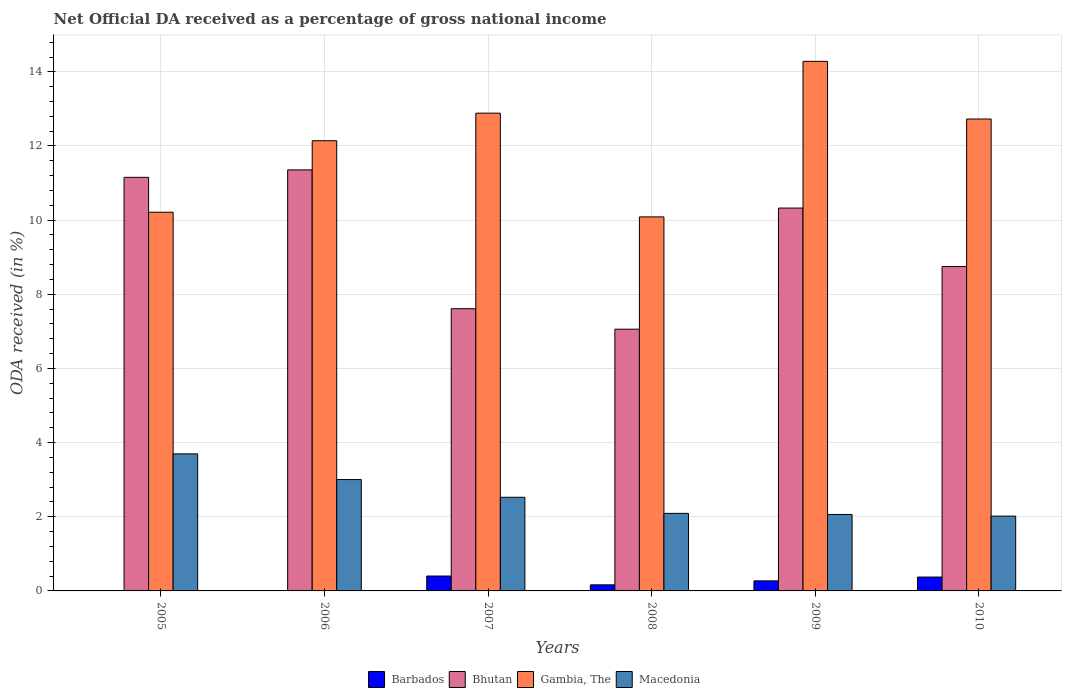How many groups of bars are there?
Keep it short and to the point. 6. Are the number of bars on each tick of the X-axis equal?
Provide a short and direct response. No. What is the label of the 2nd group of bars from the left?
Ensure brevity in your answer.  2006. In how many cases, is the number of bars for a given year not equal to the number of legend labels?
Your response must be concise. 2. What is the net official DA received in Gambia, The in 2006?
Your response must be concise. 12.14. Across all years, what is the maximum net official DA received in Barbados?
Ensure brevity in your answer.  0.4. Across all years, what is the minimum net official DA received in Macedonia?
Your answer should be compact. 2.02. In which year was the net official DA received in Macedonia maximum?
Your answer should be very brief. 2005. What is the total net official DA received in Macedonia in the graph?
Keep it short and to the point. 15.4. What is the difference between the net official DA received in Gambia, The in 2007 and that in 2010?
Offer a very short reply. 0.16. What is the difference between the net official DA received in Barbados in 2010 and the net official DA received in Macedonia in 2009?
Offer a very short reply. -1.69. What is the average net official DA received in Barbados per year?
Your answer should be compact. 0.2. In the year 2010, what is the difference between the net official DA received in Bhutan and net official DA received in Macedonia?
Provide a short and direct response. 6.73. In how many years, is the net official DA received in Gambia, The greater than 11.6 %?
Your answer should be compact. 4. What is the ratio of the net official DA received in Macedonia in 2005 to that in 2008?
Offer a terse response. 1.77. What is the difference between the highest and the second highest net official DA received in Macedonia?
Your answer should be very brief. 0.69. What is the difference between the highest and the lowest net official DA received in Gambia, The?
Provide a succinct answer. 4.2. Is the sum of the net official DA received in Bhutan in 2005 and 2008 greater than the maximum net official DA received in Barbados across all years?
Keep it short and to the point. Yes. Is it the case that in every year, the sum of the net official DA received in Gambia, The and net official DA received in Bhutan is greater than the net official DA received in Macedonia?
Your answer should be very brief. Yes. Are all the bars in the graph horizontal?
Give a very brief answer. No. Are the values on the major ticks of Y-axis written in scientific E-notation?
Your response must be concise. No. Does the graph contain any zero values?
Offer a terse response. Yes. Where does the legend appear in the graph?
Ensure brevity in your answer.  Bottom center. How are the legend labels stacked?
Keep it short and to the point. Horizontal. What is the title of the graph?
Your answer should be very brief. Net Official DA received as a percentage of gross national income. What is the label or title of the X-axis?
Your answer should be compact. Years. What is the label or title of the Y-axis?
Your answer should be very brief. ODA received (in %). What is the ODA received (in %) in Barbados in 2005?
Your response must be concise. 0. What is the ODA received (in %) of Bhutan in 2005?
Offer a very short reply. 11.15. What is the ODA received (in %) of Gambia, The in 2005?
Provide a succinct answer. 10.21. What is the ODA received (in %) in Macedonia in 2005?
Your answer should be very brief. 3.7. What is the ODA received (in %) of Barbados in 2006?
Ensure brevity in your answer.  0. What is the ODA received (in %) in Bhutan in 2006?
Offer a very short reply. 11.36. What is the ODA received (in %) in Gambia, The in 2006?
Provide a short and direct response. 12.14. What is the ODA received (in %) of Macedonia in 2006?
Keep it short and to the point. 3. What is the ODA received (in %) in Barbados in 2007?
Give a very brief answer. 0.4. What is the ODA received (in %) in Bhutan in 2007?
Ensure brevity in your answer.  7.61. What is the ODA received (in %) in Gambia, The in 2007?
Make the answer very short. 12.89. What is the ODA received (in %) in Macedonia in 2007?
Your response must be concise. 2.53. What is the ODA received (in %) in Barbados in 2008?
Keep it short and to the point. 0.16. What is the ODA received (in %) of Bhutan in 2008?
Offer a very short reply. 7.06. What is the ODA received (in %) in Gambia, The in 2008?
Ensure brevity in your answer.  10.09. What is the ODA received (in %) in Macedonia in 2008?
Provide a succinct answer. 2.09. What is the ODA received (in %) of Barbados in 2009?
Keep it short and to the point. 0.27. What is the ODA received (in %) in Bhutan in 2009?
Your answer should be compact. 10.33. What is the ODA received (in %) of Gambia, The in 2009?
Your answer should be compact. 14.28. What is the ODA received (in %) in Macedonia in 2009?
Your answer should be very brief. 2.06. What is the ODA received (in %) of Barbados in 2010?
Provide a succinct answer. 0.37. What is the ODA received (in %) of Bhutan in 2010?
Offer a very short reply. 8.75. What is the ODA received (in %) of Gambia, The in 2010?
Your answer should be very brief. 12.73. What is the ODA received (in %) in Macedonia in 2010?
Provide a succinct answer. 2.02. Across all years, what is the maximum ODA received (in %) in Barbados?
Your answer should be compact. 0.4. Across all years, what is the maximum ODA received (in %) of Bhutan?
Give a very brief answer. 11.36. Across all years, what is the maximum ODA received (in %) in Gambia, The?
Your response must be concise. 14.28. Across all years, what is the maximum ODA received (in %) in Macedonia?
Ensure brevity in your answer.  3.7. Across all years, what is the minimum ODA received (in %) of Bhutan?
Offer a very short reply. 7.06. Across all years, what is the minimum ODA received (in %) of Gambia, The?
Provide a short and direct response. 10.09. Across all years, what is the minimum ODA received (in %) of Macedonia?
Your response must be concise. 2.02. What is the total ODA received (in %) of Barbados in the graph?
Provide a succinct answer. 1.21. What is the total ODA received (in %) of Bhutan in the graph?
Provide a succinct answer. 56.26. What is the total ODA received (in %) in Gambia, The in the graph?
Give a very brief answer. 72.34. What is the total ODA received (in %) of Macedonia in the graph?
Offer a terse response. 15.4. What is the difference between the ODA received (in %) of Bhutan in 2005 and that in 2006?
Offer a very short reply. -0.2. What is the difference between the ODA received (in %) of Gambia, The in 2005 and that in 2006?
Provide a succinct answer. -1.93. What is the difference between the ODA received (in %) of Macedonia in 2005 and that in 2006?
Your answer should be compact. 0.69. What is the difference between the ODA received (in %) of Bhutan in 2005 and that in 2007?
Your answer should be very brief. 3.54. What is the difference between the ODA received (in %) of Gambia, The in 2005 and that in 2007?
Ensure brevity in your answer.  -2.67. What is the difference between the ODA received (in %) of Macedonia in 2005 and that in 2007?
Provide a short and direct response. 1.17. What is the difference between the ODA received (in %) in Bhutan in 2005 and that in 2008?
Offer a terse response. 4.1. What is the difference between the ODA received (in %) of Gambia, The in 2005 and that in 2008?
Offer a terse response. 0.13. What is the difference between the ODA received (in %) in Macedonia in 2005 and that in 2008?
Your response must be concise. 1.61. What is the difference between the ODA received (in %) of Bhutan in 2005 and that in 2009?
Provide a succinct answer. 0.83. What is the difference between the ODA received (in %) in Gambia, The in 2005 and that in 2009?
Keep it short and to the point. -4.07. What is the difference between the ODA received (in %) in Macedonia in 2005 and that in 2009?
Keep it short and to the point. 1.63. What is the difference between the ODA received (in %) of Bhutan in 2005 and that in 2010?
Your response must be concise. 2.41. What is the difference between the ODA received (in %) in Gambia, The in 2005 and that in 2010?
Provide a succinct answer. -2.51. What is the difference between the ODA received (in %) of Macedonia in 2005 and that in 2010?
Ensure brevity in your answer.  1.68. What is the difference between the ODA received (in %) of Bhutan in 2006 and that in 2007?
Keep it short and to the point. 3.74. What is the difference between the ODA received (in %) of Gambia, The in 2006 and that in 2007?
Offer a terse response. -0.74. What is the difference between the ODA received (in %) of Macedonia in 2006 and that in 2007?
Provide a succinct answer. 0.48. What is the difference between the ODA received (in %) of Bhutan in 2006 and that in 2008?
Offer a terse response. 4.3. What is the difference between the ODA received (in %) in Gambia, The in 2006 and that in 2008?
Make the answer very short. 2.05. What is the difference between the ODA received (in %) in Macedonia in 2006 and that in 2008?
Make the answer very short. 0.91. What is the difference between the ODA received (in %) in Bhutan in 2006 and that in 2009?
Offer a very short reply. 1.03. What is the difference between the ODA received (in %) of Gambia, The in 2006 and that in 2009?
Ensure brevity in your answer.  -2.14. What is the difference between the ODA received (in %) of Macedonia in 2006 and that in 2009?
Make the answer very short. 0.94. What is the difference between the ODA received (in %) of Bhutan in 2006 and that in 2010?
Make the answer very short. 2.61. What is the difference between the ODA received (in %) in Gambia, The in 2006 and that in 2010?
Keep it short and to the point. -0.59. What is the difference between the ODA received (in %) of Macedonia in 2006 and that in 2010?
Keep it short and to the point. 0.99. What is the difference between the ODA received (in %) in Barbados in 2007 and that in 2008?
Give a very brief answer. 0.24. What is the difference between the ODA received (in %) of Bhutan in 2007 and that in 2008?
Your answer should be very brief. 0.55. What is the difference between the ODA received (in %) in Gambia, The in 2007 and that in 2008?
Ensure brevity in your answer.  2.8. What is the difference between the ODA received (in %) of Macedonia in 2007 and that in 2008?
Ensure brevity in your answer.  0.43. What is the difference between the ODA received (in %) of Barbados in 2007 and that in 2009?
Your answer should be very brief. 0.13. What is the difference between the ODA received (in %) in Bhutan in 2007 and that in 2009?
Offer a terse response. -2.71. What is the difference between the ODA received (in %) in Gambia, The in 2007 and that in 2009?
Give a very brief answer. -1.4. What is the difference between the ODA received (in %) in Macedonia in 2007 and that in 2009?
Offer a very short reply. 0.46. What is the difference between the ODA received (in %) of Barbados in 2007 and that in 2010?
Make the answer very short. 0.03. What is the difference between the ODA received (in %) of Bhutan in 2007 and that in 2010?
Give a very brief answer. -1.14. What is the difference between the ODA received (in %) in Gambia, The in 2007 and that in 2010?
Provide a short and direct response. 0.16. What is the difference between the ODA received (in %) of Macedonia in 2007 and that in 2010?
Keep it short and to the point. 0.51. What is the difference between the ODA received (in %) of Barbados in 2008 and that in 2009?
Provide a succinct answer. -0.11. What is the difference between the ODA received (in %) of Bhutan in 2008 and that in 2009?
Provide a succinct answer. -3.27. What is the difference between the ODA received (in %) of Gambia, The in 2008 and that in 2009?
Keep it short and to the point. -4.2. What is the difference between the ODA received (in %) of Macedonia in 2008 and that in 2009?
Provide a short and direct response. 0.03. What is the difference between the ODA received (in %) of Barbados in 2008 and that in 2010?
Offer a very short reply. -0.21. What is the difference between the ODA received (in %) of Bhutan in 2008 and that in 2010?
Provide a short and direct response. -1.69. What is the difference between the ODA received (in %) of Gambia, The in 2008 and that in 2010?
Provide a short and direct response. -2.64. What is the difference between the ODA received (in %) of Macedonia in 2008 and that in 2010?
Provide a succinct answer. 0.07. What is the difference between the ODA received (in %) of Barbados in 2009 and that in 2010?
Provide a succinct answer. -0.1. What is the difference between the ODA received (in %) of Bhutan in 2009 and that in 2010?
Your response must be concise. 1.58. What is the difference between the ODA received (in %) in Gambia, The in 2009 and that in 2010?
Give a very brief answer. 1.55. What is the difference between the ODA received (in %) of Macedonia in 2009 and that in 2010?
Your answer should be very brief. 0.04. What is the difference between the ODA received (in %) of Bhutan in 2005 and the ODA received (in %) of Gambia, The in 2006?
Offer a very short reply. -0.99. What is the difference between the ODA received (in %) in Bhutan in 2005 and the ODA received (in %) in Macedonia in 2006?
Offer a terse response. 8.15. What is the difference between the ODA received (in %) in Gambia, The in 2005 and the ODA received (in %) in Macedonia in 2006?
Offer a very short reply. 7.21. What is the difference between the ODA received (in %) of Bhutan in 2005 and the ODA received (in %) of Gambia, The in 2007?
Your answer should be compact. -1.73. What is the difference between the ODA received (in %) of Bhutan in 2005 and the ODA received (in %) of Macedonia in 2007?
Offer a terse response. 8.63. What is the difference between the ODA received (in %) of Gambia, The in 2005 and the ODA received (in %) of Macedonia in 2007?
Offer a terse response. 7.69. What is the difference between the ODA received (in %) in Bhutan in 2005 and the ODA received (in %) in Gambia, The in 2008?
Ensure brevity in your answer.  1.07. What is the difference between the ODA received (in %) in Bhutan in 2005 and the ODA received (in %) in Macedonia in 2008?
Provide a succinct answer. 9.06. What is the difference between the ODA received (in %) of Gambia, The in 2005 and the ODA received (in %) of Macedonia in 2008?
Your answer should be compact. 8.12. What is the difference between the ODA received (in %) of Bhutan in 2005 and the ODA received (in %) of Gambia, The in 2009?
Provide a short and direct response. -3.13. What is the difference between the ODA received (in %) of Bhutan in 2005 and the ODA received (in %) of Macedonia in 2009?
Provide a succinct answer. 9.09. What is the difference between the ODA received (in %) in Gambia, The in 2005 and the ODA received (in %) in Macedonia in 2009?
Provide a short and direct response. 8.15. What is the difference between the ODA received (in %) in Bhutan in 2005 and the ODA received (in %) in Gambia, The in 2010?
Keep it short and to the point. -1.57. What is the difference between the ODA received (in %) of Bhutan in 2005 and the ODA received (in %) of Macedonia in 2010?
Keep it short and to the point. 9.14. What is the difference between the ODA received (in %) in Gambia, The in 2005 and the ODA received (in %) in Macedonia in 2010?
Offer a terse response. 8.2. What is the difference between the ODA received (in %) of Bhutan in 2006 and the ODA received (in %) of Gambia, The in 2007?
Provide a short and direct response. -1.53. What is the difference between the ODA received (in %) in Bhutan in 2006 and the ODA received (in %) in Macedonia in 2007?
Ensure brevity in your answer.  8.83. What is the difference between the ODA received (in %) in Gambia, The in 2006 and the ODA received (in %) in Macedonia in 2007?
Give a very brief answer. 9.62. What is the difference between the ODA received (in %) of Bhutan in 2006 and the ODA received (in %) of Gambia, The in 2008?
Ensure brevity in your answer.  1.27. What is the difference between the ODA received (in %) in Bhutan in 2006 and the ODA received (in %) in Macedonia in 2008?
Keep it short and to the point. 9.26. What is the difference between the ODA received (in %) of Gambia, The in 2006 and the ODA received (in %) of Macedonia in 2008?
Keep it short and to the point. 10.05. What is the difference between the ODA received (in %) of Bhutan in 2006 and the ODA received (in %) of Gambia, The in 2009?
Your answer should be compact. -2.93. What is the difference between the ODA received (in %) in Bhutan in 2006 and the ODA received (in %) in Macedonia in 2009?
Provide a succinct answer. 9.29. What is the difference between the ODA received (in %) in Gambia, The in 2006 and the ODA received (in %) in Macedonia in 2009?
Offer a very short reply. 10.08. What is the difference between the ODA received (in %) of Bhutan in 2006 and the ODA received (in %) of Gambia, The in 2010?
Offer a terse response. -1.37. What is the difference between the ODA received (in %) in Bhutan in 2006 and the ODA received (in %) in Macedonia in 2010?
Make the answer very short. 9.34. What is the difference between the ODA received (in %) in Gambia, The in 2006 and the ODA received (in %) in Macedonia in 2010?
Make the answer very short. 10.12. What is the difference between the ODA received (in %) of Barbados in 2007 and the ODA received (in %) of Bhutan in 2008?
Ensure brevity in your answer.  -6.66. What is the difference between the ODA received (in %) of Barbados in 2007 and the ODA received (in %) of Gambia, The in 2008?
Provide a succinct answer. -9.69. What is the difference between the ODA received (in %) of Barbados in 2007 and the ODA received (in %) of Macedonia in 2008?
Your response must be concise. -1.69. What is the difference between the ODA received (in %) in Bhutan in 2007 and the ODA received (in %) in Gambia, The in 2008?
Keep it short and to the point. -2.48. What is the difference between the ODA received (in %) in Bhutan in 2007 and the ODA received (in %) in Macedonia in 2008?
Offer a very short reply. 5.52. What is the difference between the ODA received (in %) of Gambia, The in 2007 and the ODA received (in %) of Macedonia in 2008?
Offer a terse response. 10.79. What is the difference between the ODA received (in %) in Barbados in 2007 and the ODA received (in %) in Bhutan in 2009?
Provide a short and direct response. -9.92. What is the difference between the ODA received (in %) of Barbados in 2007 and the ODA received (in %) of Gambia, The in 2009?
Keep it short and to the point. -13.88. What is the difference between the ODA received (in %) of Barbados in 2007 and the ODA received (in %) of Macedonia in 2009?
Offer a terse response. -1.66. What is the difference between the ODA received (in %) of Bhutan in 2007 and the ODA received (in %) of Gambia, The in 2009?
Keep it short and to the point. -6.67. What is the difference between the ODA received (in %) in Bhutan in 2007 and the ODA received (in %) in Macedonia in 2009?
Offer a very short reply. 5.55. What is the difference between the ODA received (in %) of Gambia, The in 2007 and the ODA received (in %) of Macedonia in 2009?
Keep it short and to the point. 10.82. What is the difference between the ODA received (in %) of Barbados in 2007 and the ODA received (in %) of Bhutan in 2010?
Give a very brief answer. -8.35. What is the difference between the ODA received (in %) in Barbados in 2007 and the ODA received (in %) in Gambia, The in 2010?
Ensure brevity in your answer.  -12.33. What is the difference between the ODA received (in %) in Barbados in 2007 and the ODA received (in %) in Macedonia in 2010?
Provide a short and direct response. -1.62. What is the difference between the ODA received (in %) of Bhutan in 2007 and the ODA received (in %) of Gambia, The in 2010?
Offer a terse response. -5.12. What is the difference between the ODA received (in %) in Bhutan in 2007 and the ODA received (in %) in Macedonia in 2010?
Offer a terse response. 5.59. What is the difference between the ODA received (in %) of Gambia, The in 2007 and the ODA received (in %) of Macedonia in 2010?
Provide a succinct answer. 10.87. What is the difference between the ODA received (in %) of Barbados in 2008 and the ODA received (in %) of Bhutan in 2009?
Your response must be concise. -10.16. What is the difference between the ODA received (in %) of Barbados in 2008 and the ODA received (in %) of Gambia, The in 2009?
Your response must be concise. -14.12. What is the difference between the ODA received (in %) of Barbados in 2008 and the ODA received (in %) of Macedonia in 2009?
Provide a succinct answer. -1.9. What is the difference between the ODA received (in %) of Bhutan in 2008 and the ODA received (in %) of Gambia, The in 2009?
Give a very brief answer. -7.22. What is the difference between the ODA received (in %) of Bhutan in 2008 and the ODA received (in %) of Macedonia in 2009?
Make the answer very short. 5. What is the difference between the ODA received (in %) in Gambia, The in 2008 and the ODA received (in %) in Macedonia in 2009?
Keep it short and to the point. 8.03. What is the difference between the ODA received (in %) in Barbados in 2008 and the ODA received (in %) in Bhutan in 2010?
Make the answer very short. -8.58. What is the difference between the ODA received (in %) in Barbados in 2008 and the ODA received (in %) in Gambia, The in 2010?
Your response must be concise. -12.56. What is the difference between the ODA received (in %) in Barbados in 2008 and the ODA received (in %) in Macedonia in 2010?
Offer a terse response. -1.85. What is the difference between the ODA received (in %) in Bhutan in 2008 and the ODA received (in %) in Gambia, The in 2010?
Your response must be concise. -5.67. What is the difference between the ODA received (in %) of Bhutan in 2008 and the ODA received (in %) of Macedonia in 2010?
Offer a terse response. 5.04. What is the difference between the ODA received (in %) of Gambia, The in 2008 and the ODA received (in %) of Macedonia in 2010?
Provide a succinct answer. 8.07. What is the difference between the ODA received (in %) of Barbados in 2009 and the ODA received (in %) of Bhutan in 2010?
Provide a short and direct response. -8.48. What is the difference between the ODA received (in %) in Barbados in 2009 and the ODA received (in %) in Gambia, The in 2010?
Your answer should be very brief. -12.46. What is the difference between the ODA received (in %) in Barbados in 2009 and the ODA received (in %) in Macedonia in 2010?
Your answer should be compact. -1.75. What is the difference between the ODA received (in %) of Bhutan in 2009 and the ODA received (in %) of Gambia, The in 2010?
Your answer should be very brief. -2.4. What is the difference between the ODA received (in %) of Bhutan in 2009 and the ODA received (in %) of Macedonia in 2010?
Your answer should be compact. 8.31. What is the difference between the ODA received (in %) of Gambia, The in 2009 and the ODA received (in %) of Macedonia in 2010?
Your answer should be compact. 12.26. What is the average ODA received (in %) in Barbados per year?
Keep it short and to the point. 0.2. What is the average ODA received (in %) of Bhutan per year?
Provide a succinct answer. 9.38. What is the average ODA received (in %) in Gambia, The per year?
Provide a short and direct response. 12.06. What is the average ODA received (in %) of Macedonia per year?
Offer a terse response. 2.57. In the year 2005, what is the difference between the ODA received (in %) in Bhutan and ODA received (in %) in Gambia, The?
Your response must be concise. 0.94. In the year 2005, what is the difference between the ODA received (in %) of Bhutan and ODA received (in %) of Macedonia?
Your answer should be very brief. 7.46. In the year 2005, what is the difference between the ODA received (in %) of Gambia, The and ODA received (in %) of Macedonia?
Provide a short and direct response. 6.52. In the year 2006, what is the difference between the ODA received (in %) in Bhutan and ODA received (in %) in Gambia, The?
Your response must be concise. -0.79. In the year 2006, what is the difference between the ODA received (in %) in Bhutan and ODA received (in %) in Macedonia?
Your answer should be compact. 8.35. In the year 2006, what is the difference between the ODA received (in %) of Gambia, The and ODA received (in %) of Macedonia?
Keep it short and to the point. 9.14. In the year 2007, what is the difference between the ODA received (in %) of Barbados and ODA received (in %) of Bhutan?
Ensure brevity in your answer.  -7.21. In the year 2007, what is the difference between the ODA received (in %) in Barbados and ODA received (in %) in Gambia, The?
Keep it short and to the point. -12.48. In the year 2007, what is the difference between the ODA received (in %) of Barbados and ODA received (in %) of Macedonia?
Your response must be concise. -2.12. In the year 2007, what is the difference between the ODA received (in %) of Bhutan and ODA received (in %) of Gambia, The?
Provide a succinct answer. -5.27. In the year 2007, what is the difference between the ODA received (in %) of Bhutan and ODA received (in %) of Macedonia?
Offer a very short reply. 5.09. In the year 2007, what is the difference between the ODA received (in %) of Gambia, The and ODA received (in %) of Macedonia?
Ensure brevity in your answer.  10.36. In the year 2008, what is the difference between the ODA received (in %) of Barbados and ODA received (in %) of Bhutan?
Your answer should be compact. -6.9. In the year 2008, what is the difference between the ODA received (in %) in Barbados and ODA received (in %) in Gambia, The?
Your answer should be very brief. -9.92. In the year 2008, what is the difference between the ODA received (in %) of Barbados and ODA received (in %) of Macedonia?
Give a very brief answer. -1.93. In the year 2008, what is the difference between the ODA received (in %) of Bhutan and ODA received (in %) of Gambia, The?
Make the answer very short. -3.03. In the year 2008, what is the difference between the ODA received (in %) in Bhutan and ODA received (in %) in Macedonia?
Your answer should be compact. 4.97. In the year 2008, what is the difference between the ODA received (in %) of Gambia, The and ODA received (in %) of Macedonia?
Your answer should be compact. 8. In the year 2009, what is the difference between the ODA received (in %) of Barbados and ODA received (in %) of Bhutan?
Keep it short and to the point. -10.06. In the year 2009, what is the difference between the ODA received (in %) of Barbados and ODA received (in %) of Gambia, The?
Ensure brevity in your answer.  -14.01. In the year 2009, what is the difference between the ODA received (in %) of Barbados and ODA received (in %) of Macedonia?
Provide a succinct answer. -1.79. In the year 2009, what is the difference between the ODA received (in %) of Bhutan and ODA received (in %) of Gambia, The?
Provide a succinct answer. -3.96. In the year 2009, what is the difference between the ODA received (in %) of Bhutan and ODA received (in %) of Macedonia?
Your answer should be very brief. 8.26. In the year 2009, what is the difference between the ODA received (in %) in Gambia, The and ODA received (in %) in Macedonia?
Provide a short and direct response. 12.22. In the year 2010, what is the difference between the ODA received (in %) in Barbados and ODA received (in %) in Bhutan?
Offer a very short reply. -8.37. In the year 2010, what is the difference between the ODA received (in %) of Barbados and ODA received (in %) of Gambia, The?
Provide a succinct answer. -12.35. In the year 2010, what is the difference between the ODA received (in %) in Barbados and ODA received (in %) in Macedonia?
Give a very brief answer. -1.64. In the year 2010, what is the difference between the ODA received (in %) in Bhutan and ODA received (in %) in Gambia, The?
Offer a terse response. -3.98. In the year 2010, what is the difference between the ODA received (in %) of Bhutan and ODA received (in %) of Macedonia?
Offer a terse response. 6.73. In the year 2010, what is the difference between the ODA received (in %) of Gambia, The and ODA received (in %) of Macedonia?
Give a very brief answer. 10.71. What is the ratio of the ODA received (in %) in Bhutan in 2005 to that in 2006?
Your response must be concise. 0.98. What is the ratio of the ODA received (in %) of Gambia, The in 2005 to that in 2006?
Make the answer very short. 0.84. What is the ratio of the ODA received (in %) in Macedonia in 2005 to that in 2006?
Ensure brevity in your answer.  1.23. What is the ratio of the ODA received (in %) in Bhutan in 2005 to that in 2007?
Provide a short and direct response. 1.47. What is the ratio of the ODA received (in %) of Gambia, The in 2005 to that in 2007?
Your answer should be very brief. 0.79. What is the ratio of the ODA received (in %) of Macedonia in 2005 to that in 2007?
Keep it short and to the point. 1.46. What is the ratio of the ODA received (in %) of Bhutan in 2005 to that in 2008?
Give a very brief answer. 1.58. What is the ratio of the ODA received (in %) in Gambia, The in 2005 to that in 2008?
Offer a very short reply. 1.01. What is the ratio of the ODA received (in %) of Macedonia in 2005 to that in 2008?
Provide a succinct answer. 1.77. What is the ratio of the ODA received (in %) of Bhutan in 2005 to that in 2009?
Make the answer very short. 1.08. What is the ratio of the ODA received (in %) in Gambia, The in 2005 to that in 2009?
Your response must be concise. 0.72. What is the ratio of the ODA received (in %) of Macedonia in 2005 to that in 2009?
Your answer should be very brief. 1.79. What is the ratio of the ODA received (in %) in Bhutan in 2005 to that in 2010?
Make the answer very short. 1.28. What is the ratio of the ODA received (in %) of Gambia, The in 2005 to that in 2010?
Ensure brevity in your answer.  0.8. What is the ratio of the ODA received (in %) of Macedonia in 2005 to that in 2010?
Your response must be concise. 1.83. What is the ratio of the ODA received (in %) of Bhutan in 2006 to that in 2007?
Provide a succinct answer. 1.49. What is the ratio of the ODA received (in %) in Gambia, The in 2006 to that in 2007?
Offer a very short reply. 0.94. What is the ratio of the ODA received (in %) of Macedonia in 2006 to that in 2007?
Provide a short and direct response. 1.19. What is the ratio of the ODA received (in %) in Bhutan in 2006 to that in 2008?
Make the answer very short. 1.61. What is the ratio of the ODA received (in %) in Gambia, The in 2006 to that in 2008?
Provide a succinct answer. 1.2. What is the ratio of the ODA received (in %) in Macedonia in 2006 to that in 2008?
Provide a short and direct response. 1.44. What is the ratio of the ODA received (in %) of Bhutan in 2006 to that in 2009?
Make the answer very short. 1.1. What is the ratio of the ODA received (in %) of Gambia, The in 2006 to that in 2009?
Ensure brevity in your answer.  0.85. What is the ratio of the ODA received (in %) in Macedonia in 2006 to that in 2009?
Ensure brevity in your answer.  1.46. What is the ratio of the ODA received (in %) in Bhutan in 2006 to that in 2010?
Offer a terse response. 1.3. What is the ratio of the ODA received (in %) of Gambia, The in 2006 to that in 2010?
Ensure brevity in your answer.  0.95. What is the ratio of the ODA received (in %) in Macedonia in 2006 to that in 2010?
Provide a succinct answer. 1.49. What is the ratio of the ODA received (in %) of Barbados in 2007 to that in 2008?
Your answer should be very brief. 2.45. What is the ratio of the ODA received (in %) in Bhutan in 2007 to that in 2008?
Offer a terse response. 1.08. What is the ratio of the ODA received (in %) of Gambia, The in 2007 to that in 2008?
Your answer should be compact. 1.28. What is the ratio of the ODA received (in %) of Macedonia in 2007 to that in 2008?
Provide a short and direct response. 1.21. What is the ratio of the ODA received (in %) in Barbados in 2007 to that in 2009?
Your answer should be compact. 1.48. What is the ratio of the ODA received (in %) of Bhutan in 2007 to that in 2009?
Give a very brief answer. 0.74. What is the ratio of the ODA received (in %) of Gambia, The in 2007 to that in 2009?
Your answer should be very brief. 0.9. What is the ratio of the ODA received (in %) in Macedonia in 2007 to that in 2009?
Provide a short and direct response. 1.23. What is the ratio of the ODA received (in %) in Barbados in 2007 to that in 2010?
Provide a succinct answer. 1.07. What is the ratio of the ODA received (in %) in Bhutan in 2007 to that in 2010?
Offer a very short reply. 0.87. What is the ratio of the ODA received (in %) of Gambia, The in 2007 to that in 2010?
Offer a very short reply. 1.01. What is the ratio of the ODA received (in %) in Macedonia in 2007 to that in 2010?
Offer a terse response. 1.25. What is the ratio of the ODA received (in %) of Barbados in 2008 to that in 2009?
Offer a very short reply. 0.6. What is the ratio of the ODA received (in %) in Bhutan in 2008 to that in 2009?
Keep it short and to the point. 0.68. What is the ratio of the ODA received (in %) of Gambia, The in 2008 to that in 2009?
Ensure brevity in your answer.  0.71. What is the ratio of the ODA received (in %) of Macedonia in 2008 to that in 2009?
Your answer should be very brief. 1.01. What is the ratio of the ODA received (in %) in Barbados in 2008 to that in 2010?
Ensure brevity in your answer.  0.44. What is the ratio of the ODA received (in %) in Bhutan in 2008 to that in 2010?
Keep it short and to the point. 0.81. What is the ratio of the ODA received (in %) in Gambia, The in 2008 to that in 2010?
Offer a terse response. 0.79. What is the ratio of the ODA received (in %) of Macedonia in 2008 to that in 2010?
Give a very brief answer. 1.04. What is the ratio of the ODA received (in %) in Barbados in 2009 to that in 2010?
Your response must be concise. 0.73. What is the ratio of the ODA received (in %) of Bhutan in 2009 to that in 2010?
Provide a short and direct response. 1.18. What is the ratio of the ODA received (in %) of Gambia, The in 2009 to that in 2010?
Provide a short and direct response. 1.12. What is the ratio of the ODA received (in %) of Macedonia in 2009 to that in 2010?
Your answer should be compact. 1.02. What is the difference between the highest and the second highest ODA received (in %) of Barbados?
Ensure brevity in your answer.  0.03. What is the difference between the highest and the second highest ODA received (in %) of Bhutan?
Give a very brief answer. 0.2. What is the difference between the highest and the second highest ODA received (in %) in Gambia, The?
Provide a short and direct response. 1.4. What is the difference between the highest and the second highest ODA received (in %) in Macedonia?
Make the answer very short. 0.69. What is the difference between the highest and the lowest ODA received (in %) of Barbados?
Provide a succinct answer. 0.4. What is the difference between the highest and the lowest ODA received (in %) in Bhutan?
Provide a succinct answer. 4.3. What is the difference between the highest and the lowest ODA received (in %) in Gambia, The?
Your response must be concise. 4.2. What is the difference between the highest and the lowest ODA received (in %) of Macedonia?
Offer a terse response. 1.68. 